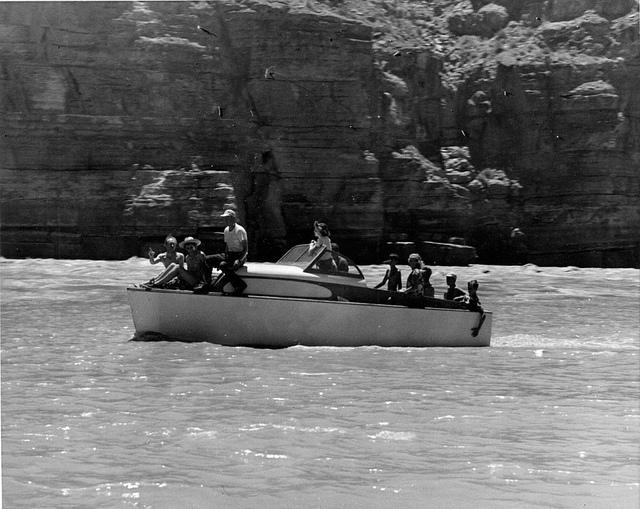Is the picture in color?
Give a very brief answer. No. How many people are on the boat?
Quick response, please. 8. Do you know how that water must feel to them if they capsized?
Quick response, please. Cold. 